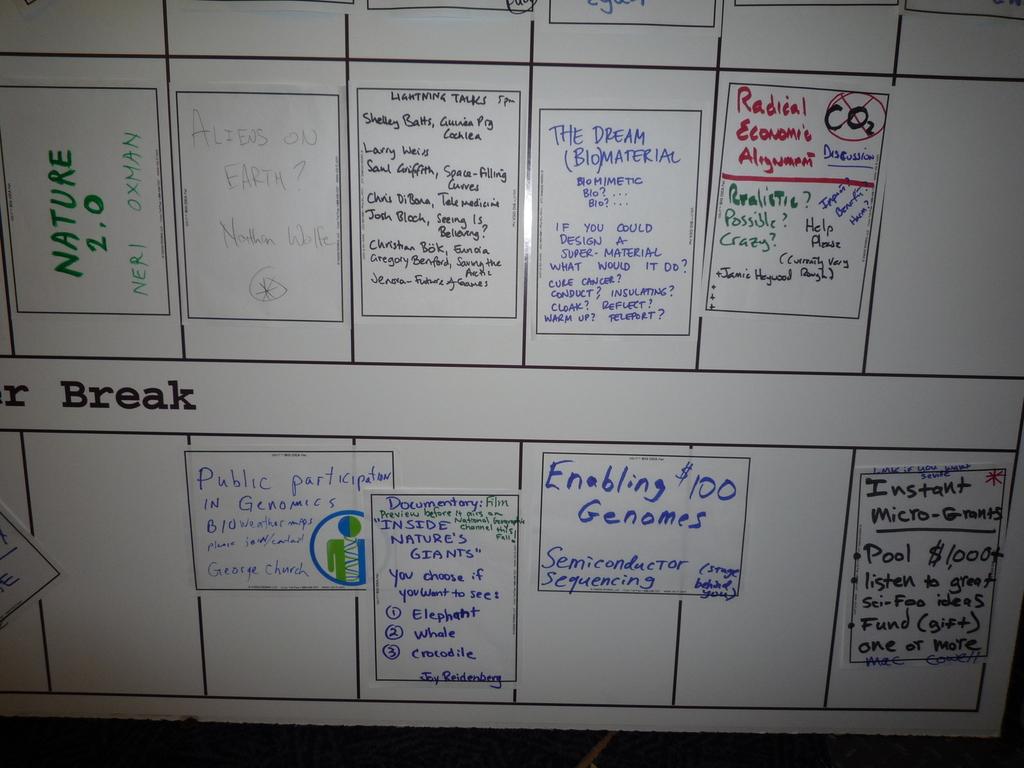What is labeled as 2.0 on the top left?
Offer a terse response. Nature. 